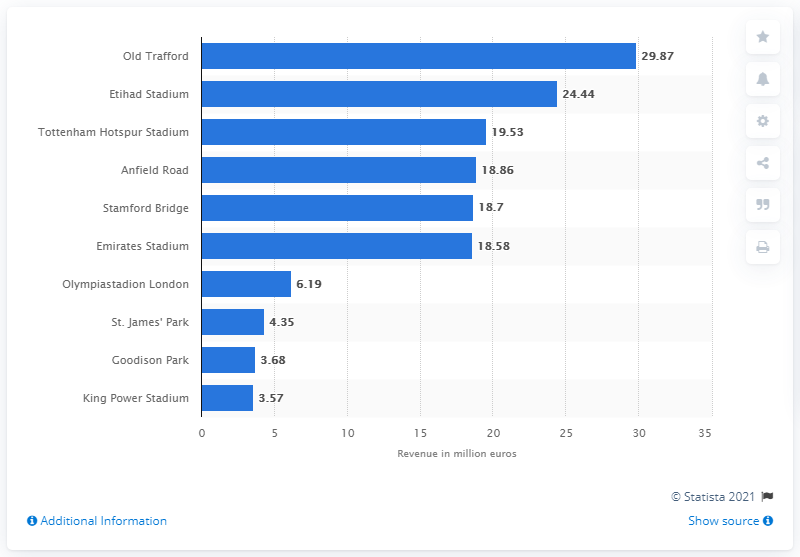Give some essential details in this illustration. Manchester City's stadium, known as the Etihad Stadium, belongs to the football club. 